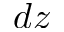Convert formula to latex. <formula><loc_0><loc_0><loc_500><loc_500>d z</formula> 